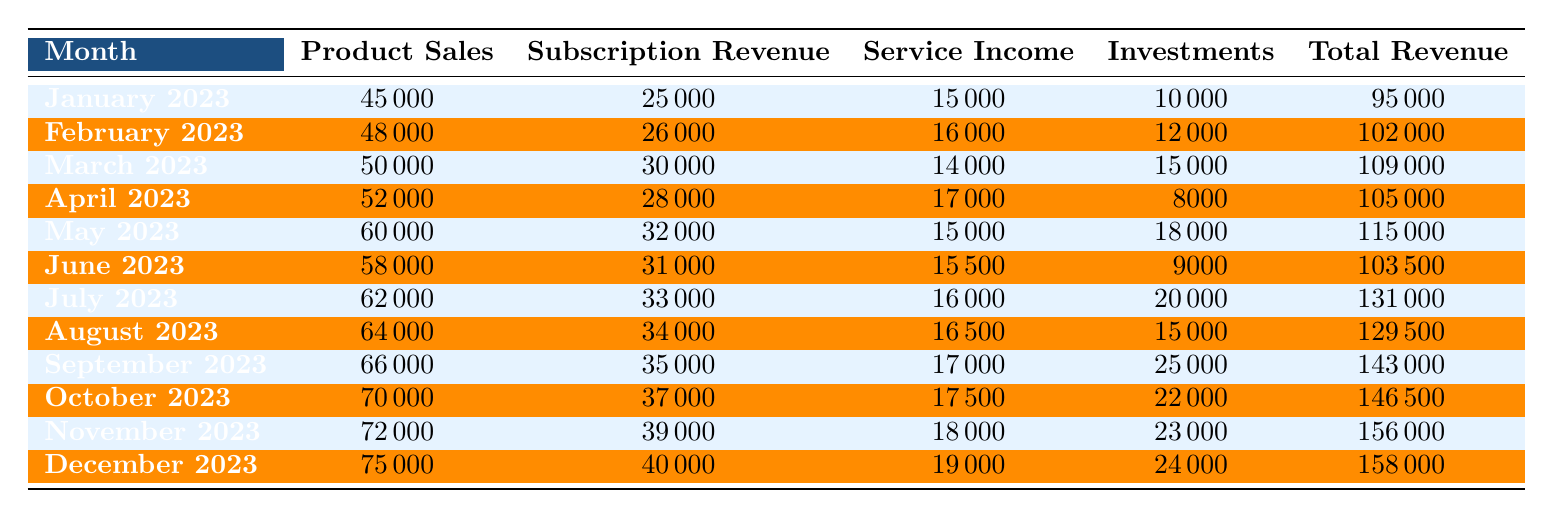What was the total revenue in October 2023? Referring to the table, the total revenue for October 2023 is explicitly listed in the last column. It shows 146,500.
Answer: 146500 How much did Product Sales increase from January to December 2023? The Product Sales for January 2023 were 45,000 and for December 2023 were 75,000. The increase is calculated as 75,000 - 45,000 = 30,000.
Answer: 30000 What was the average Subscription Revenue for the second quarter (April, May, June) of 2023? The Subscription Revenues for April, May, and June are 28,000, 32,000, and 31,000 respectively. First, sum these values: 28,000 + 32,000 + 31,000 = 91,000. Since there are 3 months, the average is 91,000 / 3 = 30,333.33.
Answer: 30333.33 Did the total revenue decrease from June to July 2023? From the table, total revenue for June 2023 is 103,500, while for July 2023 it is 131,000. Since 131,000 is greater than 103,500, the total revenue did not decrease.
Answer: No What is the difference in Service Income between the highest and lowest months? The highest Service Income was in December (19,000) and the lowest was in March (14,000). The difference is 19,000 - 14,000 = 5,000.
Answer: 5000 In which month did Product Sales first exceed 60,000? Looking at the Product Sales, we see it first exceeded 60,000 in May 2023, where it was 60,000.
Answer: May 2023 What percent of the total revenue in November 2023 comes from Investments? In November 2023, the total revenue is 156,000 and the Investments amount is 23,000. The percentage is calculated as (23,000 / 156,000) * 100, which equals approximately 14.74%.
Answer: 14.74% What was the trend in Product Sales from January to December 2023? By examining the Product Sales data in the table, it consistently increased each month from 45,000 in January to 75,000 in December, indicating a positive trend.
Answer: Consistently increased Which month had the highest Total Revenue, and what was that revenue? The table shows December 2023 had the highest total revenue of 158,000.
Answer: December 2023, 158000 Was the total revenue in September higher than in August 2023? The total revenue in September 2023 is 143,000, while in August it is 129,500. Since 143,000 is greater than 129,500, September's total revenue was higher.
Answer: Yes 